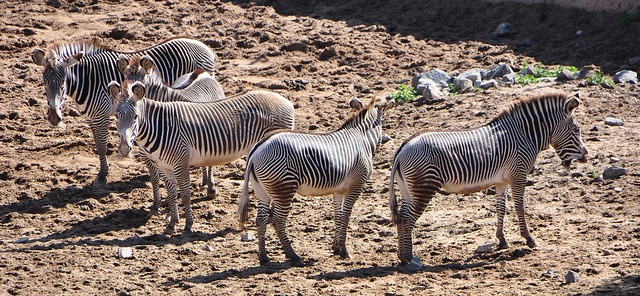Describe the objects in this image and their specific colors. I can see zebra in gray, black, and darkgray tones, zebra in gray, black, darkgray, and lightgray tones, zebra in gray, black, and darkgray tones, zebra in gray, black, darkgray, and lightgray tones, and zebra in gray, lightgray, darkgray, and black tones in this image. 